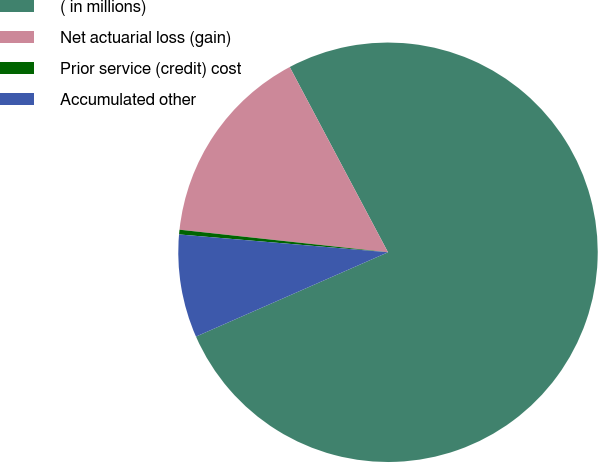Convert chart to OTSL. <chart><loc_0><loc_0><loc_500><loc_500><pie_chart><fcel>( in millions)<fcel>Net actuarial loss (gain)<fcel>Prior service (credit) cost<fcel>Accumulated other<nl><fcel>76.17%<fcel>15.52%<fcel>0.36%<fcel>7.94%<nl></chart> 